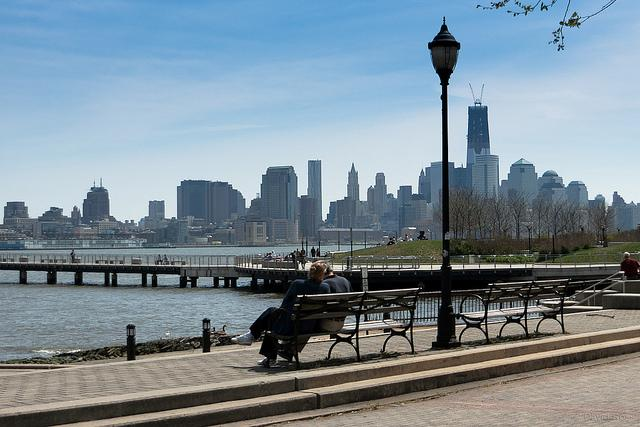Who is this area designed for? tourists 